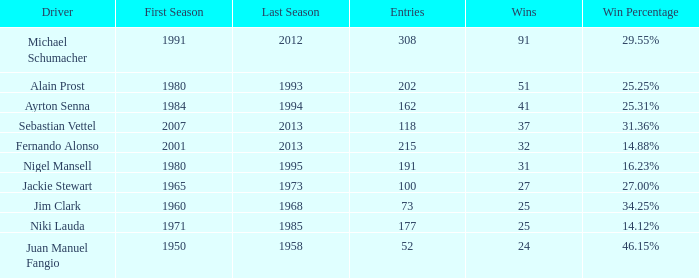Which driver has 162 entries? Ayrton Senna. 